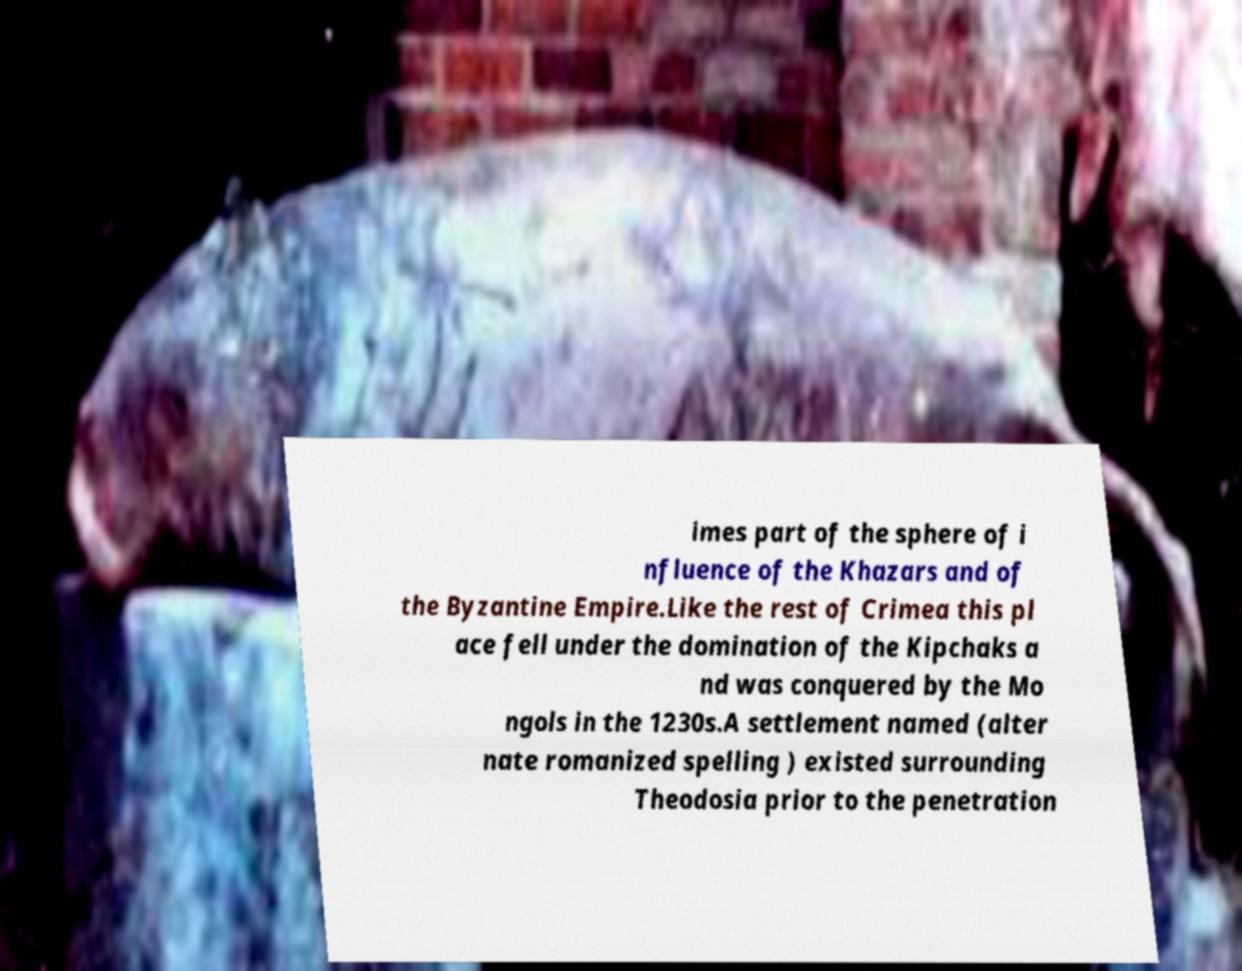I need the written content from this picture converted into text. Can you do that? imes part of the sphere of i nfluence of the Khazars and of the Byzantine Empire.Like the rest of Crimea this pl ace fell under the domination of the Kipchaks a nd was conquered by the Mo ngols in the 1230s.A settlement named (alter nate romanized spelling ) existed surrounding Theodosia prior to the penetration 